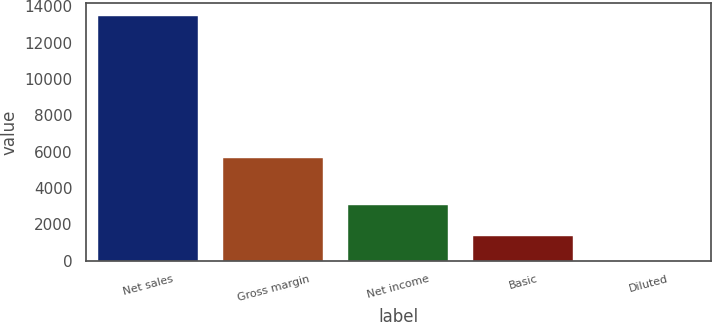Convert chart. <chart><loc_0><loc_0><loc_500><loc_500><bar_chart><fcel>Net sales<fcel>Gross margin<fcel>Net income<fcel>Basic<fcel>Diluted<nl><fcel>13499<fcel>5625<fcel>3074<fcel>1352.9<fcel>3.33<nl></chart> 